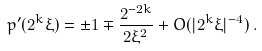Convert formula to latex. <formula><loc_0><loc_0><loc_500><loc_500>p ^ { \prime } ( 2 ^ { k } \xi ) = \pm 1 \mp \frac { 2 ^ { - 2 k } } { 2 \xi ^ { 2 } } + O ( | 2 ^ { k } \xi | ^ { - 4 } ) \, .</formula> 